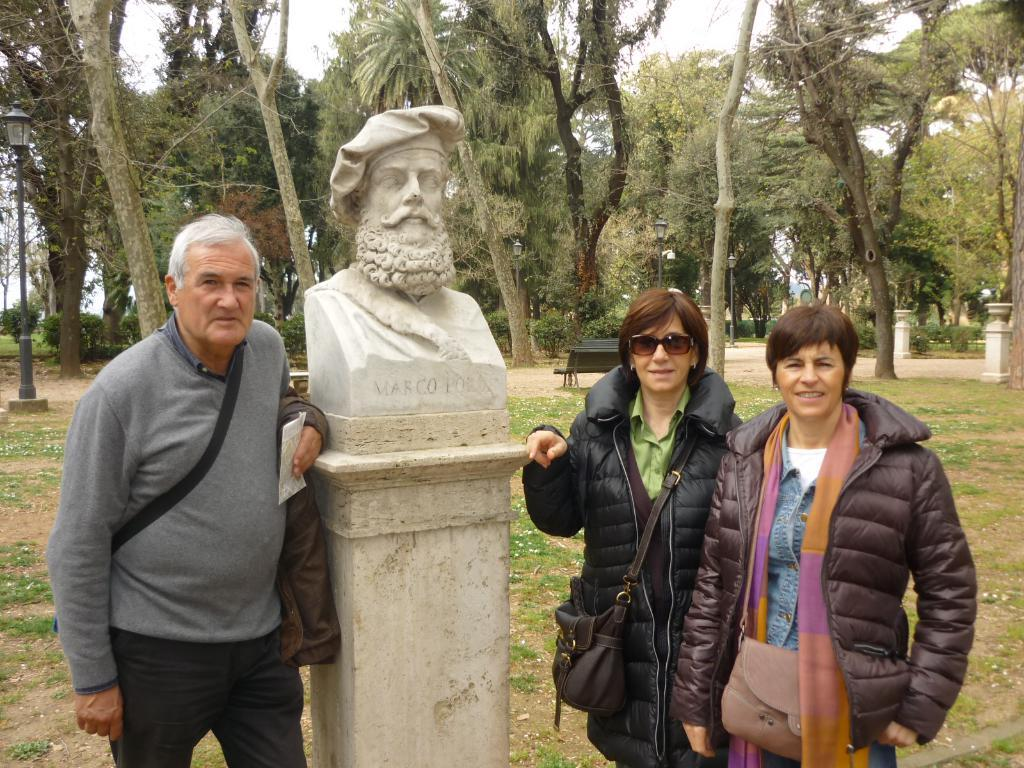What is the main subject in the middle of the image? There is a statue in the middle of the image. Where are the people located in the image? There are people on the left side and the right side of the image. What can be seen in the background of the image? There are trees visible in the background of the image. What type of art can be seen in the library in the image? There is no library or art present in the image; it features a statue and people in a setting with trees in the background. Can you see any steam coming from the statue in the image? There is no steam visible in the image. 